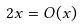<formula> <loc_0><loc_0><loc_500><loc_500>2 x = O ( x )</formula> 